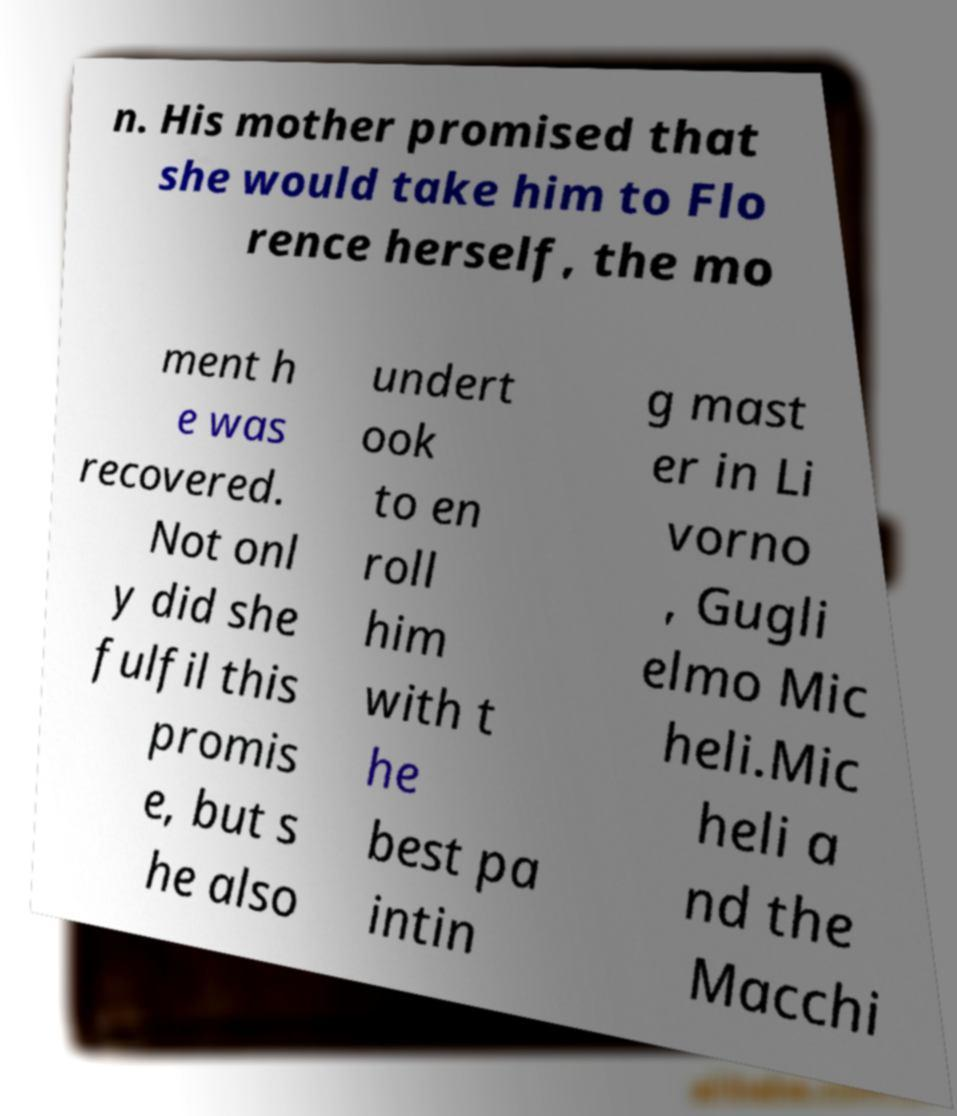Could you extract and type out the text from this image? n. His mother promised that she would take him to Flo rence herself, the mo ment h e was recovered. Not onl y did she fulfil this promis e, but s he also undert ook to en roll him with t he best pa intin g mast er in Li vorno , Gugli elmo Mic heli.Mic heli a nd the Macchi 